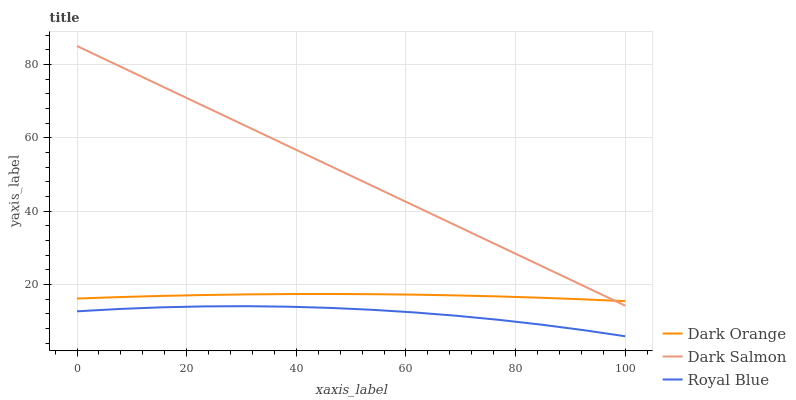Does Royal Blue have the minimum area under the curve?
Answer yes or no. Yes. Does Dark Salmon have the maximum area under the curve?
Answer yes or no. Yes. Does Dark Salmon have the minimum area under the curve?
Answer yes or no. No. Does Royal Blue have the maximum area under the curve?
Answer yes or no. No. Is Dark Salmon the smoothest?
Answer yes or no. Yes. Is Royal Blue the roughest?
Answer yes or no. Yes. Is Royal Blue the smoothest?
Answer yes or no. No. Is Dark Salmon the roughest?
Answer yes or no. No. Does Royal Blue have the lowest value?
Answer yes or no. Yes. Does Dark Salmon have the lowest value?
Answer yes or no. No. Does Dark Salmon have the highest value?
Answer yes or no. Yes. Does Royal Blue have the highest value?
Answer yes or no. No. Is Royal Blue less than Dark Salmon?
Answer yes or no. Yes. Is Dark Salmon greater than Royal Blue?
Answer yes or no. Yes. Does Dark Salmon intersect Dark Orange?
Answer yes or no. Yes. Is Dark Salmon less than Dark Orange?
Answer yes or no. No. Is Dark Salmon greater than Dark Orange?
Answer yes or no. No. Does Royal Blue intersect Dark Salmon?
Answer yes or no. No. 